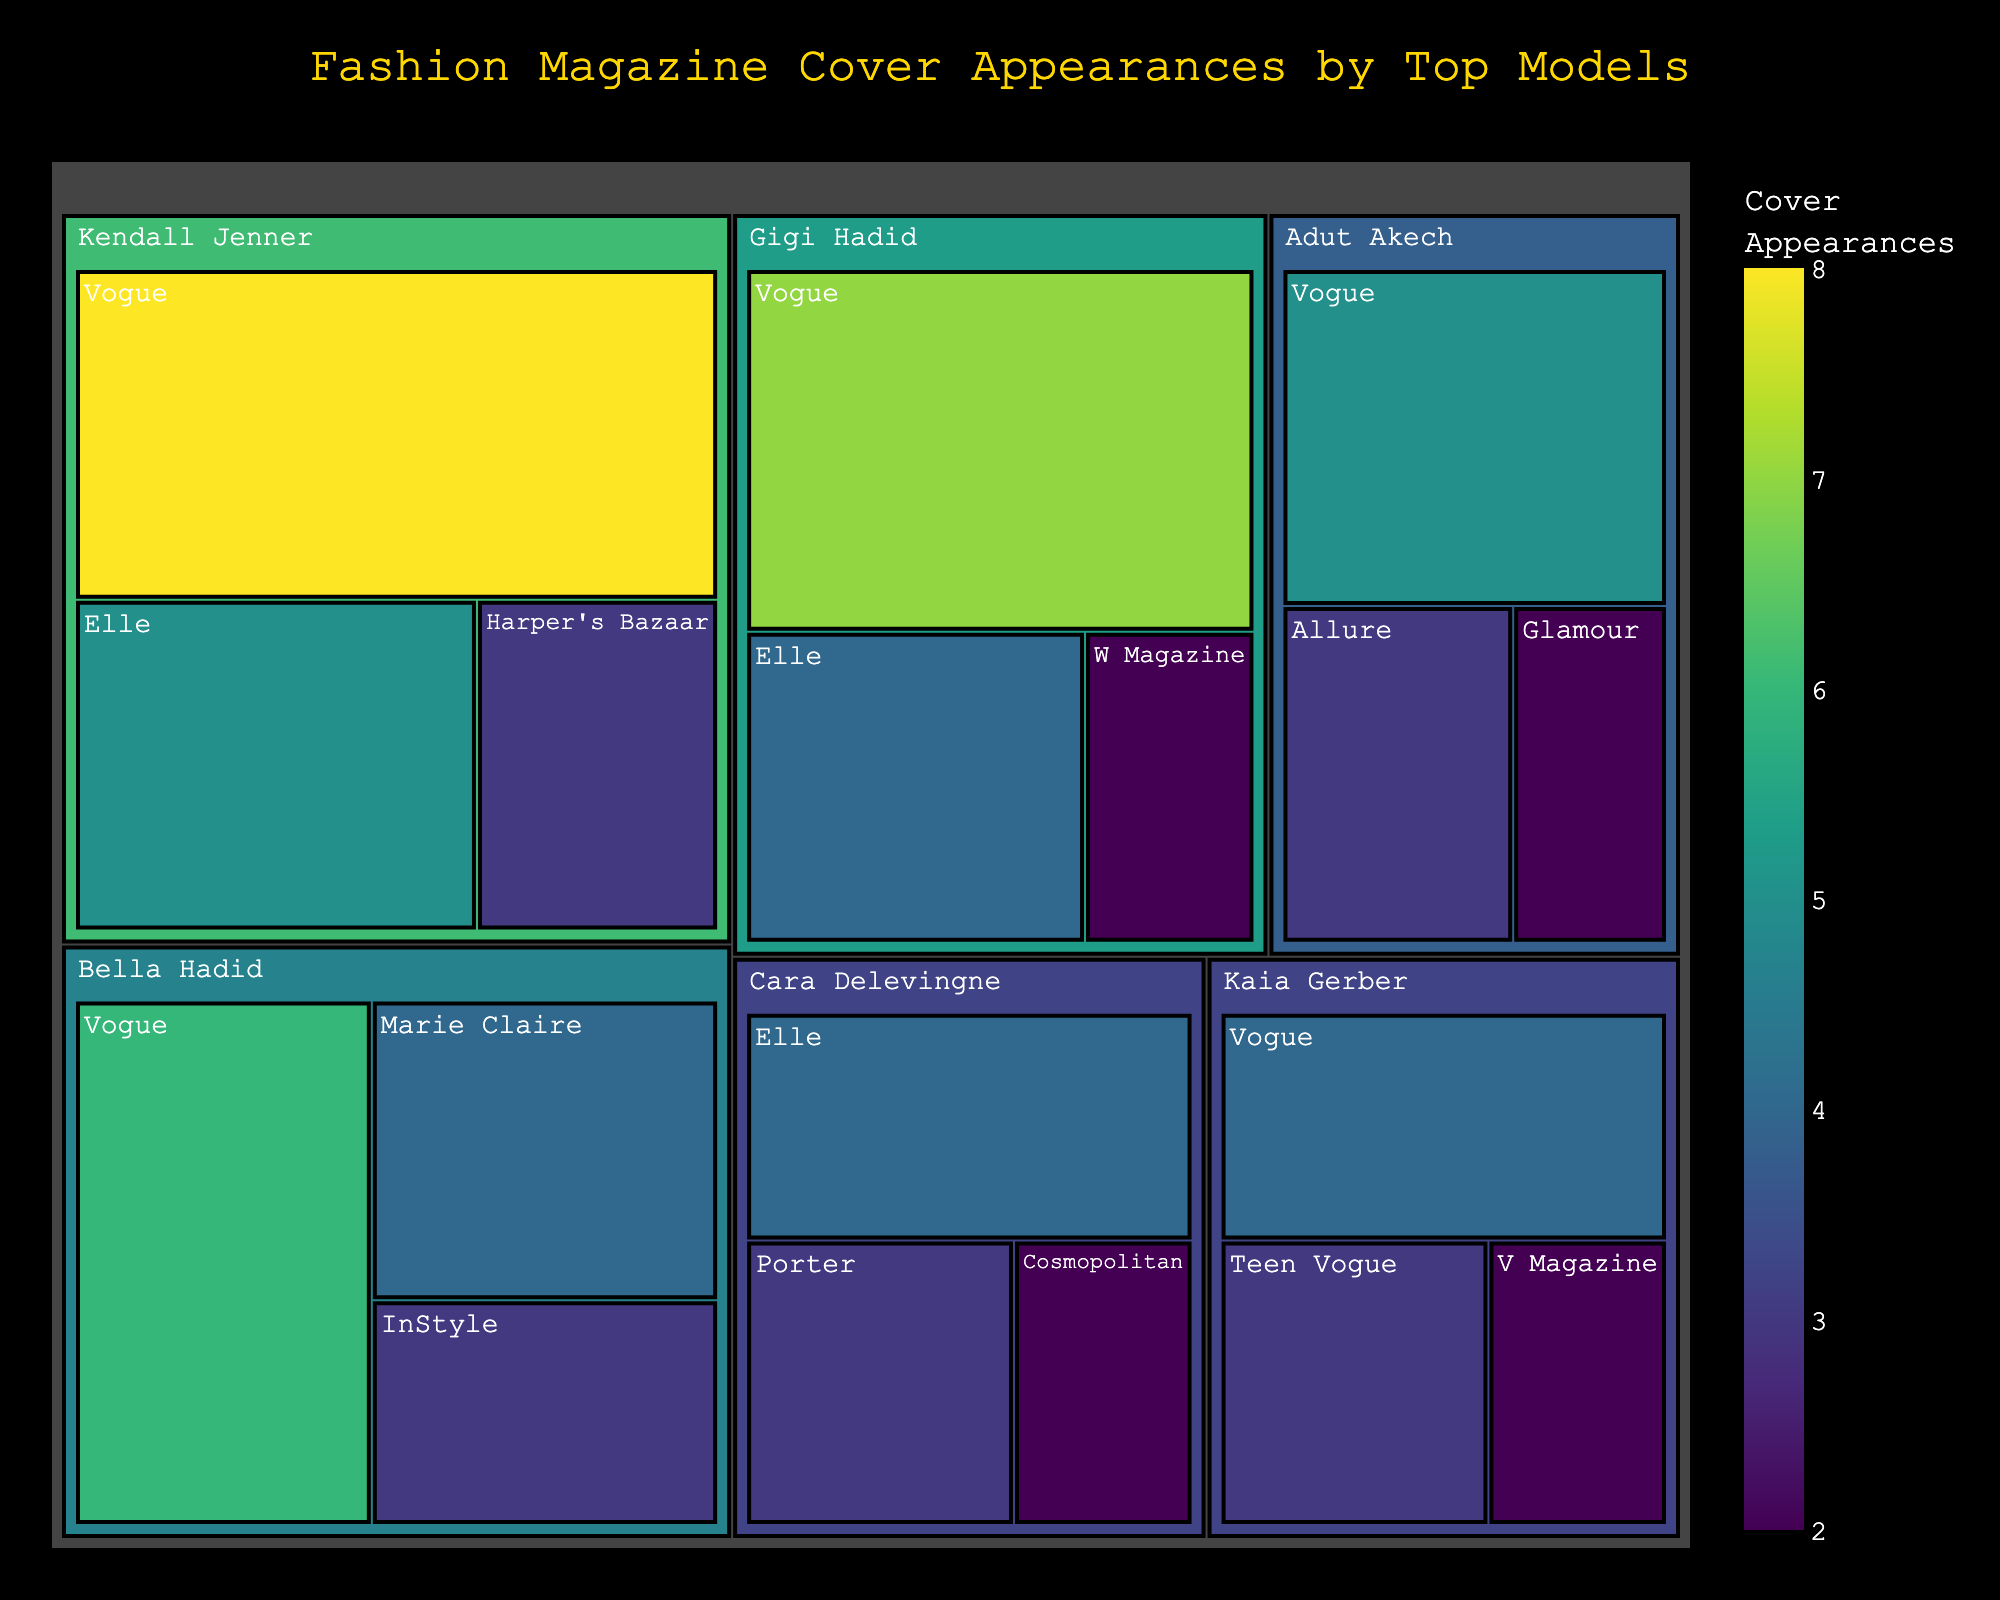What's the title of the figure? The title of the figure is typically displayed at the top of the plot and represents the main theme or summary of the visual data.
Answer: Fashion Magazine Cover Appearances by Top Models Which model has the most total appearances on magazine covers? To determine which model has the most total appearances, sum the appearances across all magazines for each model and compare the totals. Kendall Jenner has 16 (8+5+3), Gigi Hadid has 13 (7+4+2), Bella Hadid has 13 (6+4+3), Adut Akech has 10 (5+3+2), Kaia Gerber has 9 (4+3+2), and Cara Delevingne has 9 (4+3+2). So, Kendall Jenner has the most.
Answer: Kendall Jenner How many cover appearances does Bella Hadid have in Marie Claire and InStyle combined? Look at the treemap to find Bella Hadid's cover appearances for Marie Claire and InStyle, then sum these values: 4 (Marie Claire) + 3 (InStyle).
Answer: 7 Which model has the most appearances on Vogue? Locate each model's number of Vogue appearances in the treemap: Kendall Jenner (8), Gigi Hadid (7), Bella Hadid (6), Adut Akech (5), Kaia Gerber (4). The highest number is held by Kendall Jenner with 8 appearances.
Answer: Kendall Jenner Compare the total number of appearances between Kendall Jenner and Gigi Hadid. Who has more, and by how much? Calculate the total appearances for each: Kendall Jenner has 16 (8+5+3), Gigi Hadid has 13 (7+4+2). Subtract Gigi Hadid's total from Kendall Jenner's total: 16 - 13.
Answer: Kendall Jenner by 3 Which magazine features the highest number of cover appearances by all models? Sum the appearances for each magazine across all models and identify the magazine with the highest total: Vogue (8+7+6+5+4) = 30, Elle (5+4+4) = 13, Harper's Bazaar (3) = 3, W Magazine (2) = 2, Marie Claire (4) = 4, InStyle (3) = 3, Allure (3) = 3, Glamour (2) = 2, Teen Vogue (3) = 3, V Magazine (2) = 2, Porter (3) = 3, Cosmopolitan (2) = 2. Vogue has the highest total.
Answer: Vogue What's the total number of cover appearances for Kaia Gerber? Sum Kaia Gerber's appearances across all magazines: 4 (Vogue) + 3 (Teen Vogue) + 2 (V Magazine).
Answer: 9 Which model has the fewest number of total appearances? Sum the total appearances for each model and compare: Kendall Jenner (16), Gigi Hadid (13), Bella Hadid (13), Adut Akech (10), Kaia Gerber (9), Cara Delevingne (9). The fewest is held by both Kaia Gerber and Cara Delevingne with 9 appearances each.
Answer: Kaia Gerber and Cara Delevingne Compare the appearances of Gigi Hadid on Vogue and Elle. By how much does one lead over the other? Identify Gigi Hadid's appearances for each magazine: Vogue (7), Elle (4). Subtract the smaller number from the larger number: 7 - 4.
Answer: Vogue by 3 What's the average number of cover appearances for all models on Elle? Sum the appearances on Elle for all models: Kendall Jenner (5), Gigi Hadid (4), Cara Delevingne (4). Count the total number of models (3), then divide the sum by the number of models: (5+4+4)/3.
Answer: 4.33 